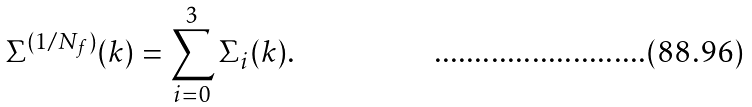Convert formula to latex. <formula><loc_0><loc_0><loc_500><loc_500>\Sigma ^ { ( 1 / N _ { f } ) } ( k ) = \sum _ { i = 0 } ^ { 3 } \Sigma _ { i } ( k ) \text {.}</formula> 